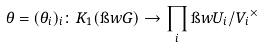Convert formula to latex. <formula><loc_0><loc_0><loc_500><loc_500>\theta = ( \theta _ { i } ) _ { i } \colon K _ { 1 } ( \i w { G } ) \rightarrow \prod _ { i } \i w { U _ { i } / V _ { i } } ^ { \times }</formula> 